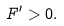<formula> <loc_0><loc_0><loc_500><loc_500>F ^ { \prime } > 0 .</formula> 